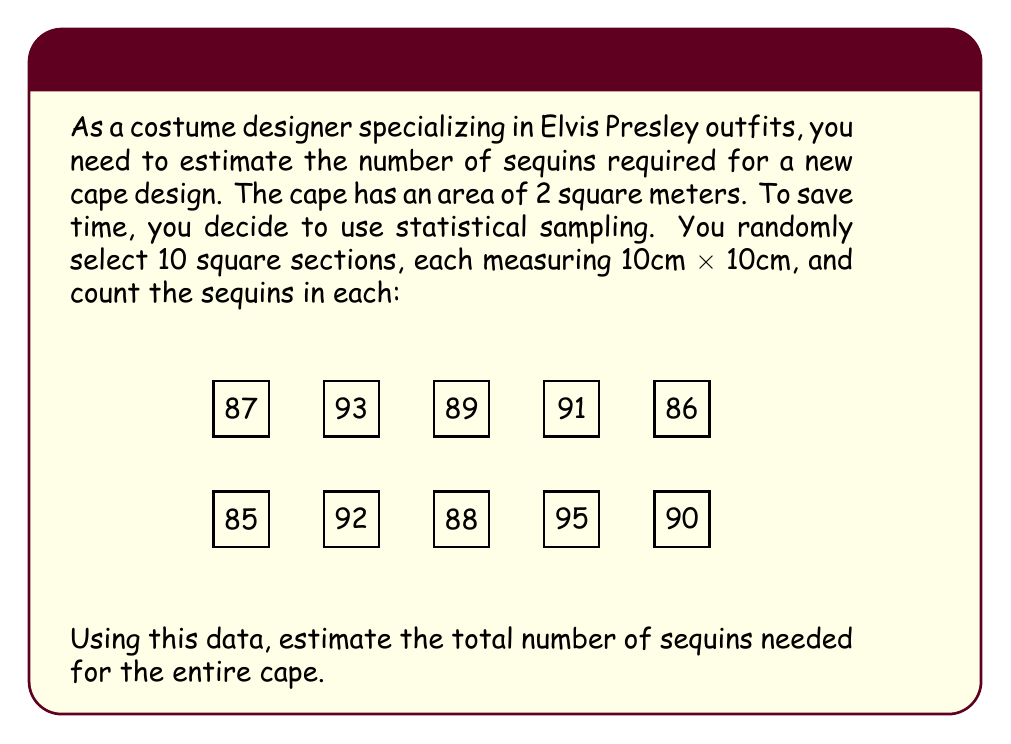Could you help me with this problem? To estimate the total number of sequins for the cape, we'll follow these steps:

1) Calculate the average number of sequins per sample:
   Sum of sequins = 85 + 92 + 88 + 95 + 90 + 87 + 93 + 89 + 91 + 86 = 896
   Average = $\frac{896}{10} = 89.6$ sequins per 100 cm²

2) Convert the cape area to cm²:
   2 m² = 20,000 cm²

3) Calculate the number of 100 cm² sections in the cape:
   Number of sections = $\frac{20,000 \text{ cm}^2}{100 \text{ cm}^2} = 200$

4) Estimate the total number of sequins:
   Estimated total = Average per section × Number of sections
   $$ \text{Estimated total} = 89.6 \times 200 = 17,920 $$

5) Round to the nearest hundred for a practical estimate:
   $$ \text{Final estimate} = 17,900 \text{ sequins} $$

This method uses the sample mean to estimate the population mean, assuming the samples are representative of the entire cape. The precision of this estimate depends on the variability of sequin density across the cape and the number of samples taken.
Answer: 17,900 sequins 